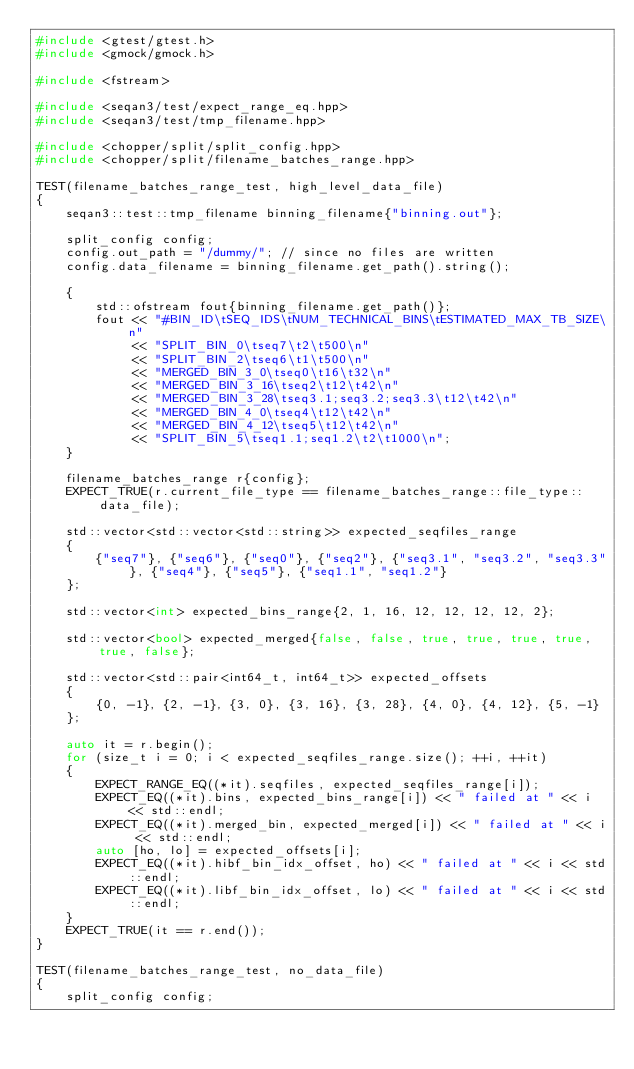<code> <loc_0><loc_0><loc_500><loc_500><_C++_>#include <gtest/gtest.h>
#include <gmock/gmock.h>

#include <fstream>

#include <seqan3/test/expect_range_eq.hpp>
#include <seqan3/test/tmp_filename.hpp>

#include <chopper/split/split_config.hpp>
#include <chopper/split/filename_batches_range.hpp>

TEST(filename_batches_range_test, high_level_data_file)
{
    seqan3::test::tmp_filename binning_filename{"binning.out"};

    split_config config;
    config.out_path = "/dummy/"; // since no files are written
    config.data_filename = binning_filename.get_path().string();

    {
        std::ofstream fout{binning_filename.get_path()};
        fout << "#BIN_ID\tSEQ_IDS\tNUM_TECHNICAL_BINS\tESTIMATED_MAX_TB_SIZE\n"
             << "SPLIT_BIN_0\tseq7\t2\t500\n"
             << "SPLIT_BIN_2\tseq6\t1\t500\n"
             << "MERGED_BIN_3_0\tseq0\t16\t32\n"
             << "MERGED_BIN_3_16\tseq2\t12\t42\n"
             << "MERGED_BIN_3_28\tseq3.1;seq3.2;seq3.3\t12\t42\n"
             << "MERGED_BIN_4_0\tseq4\t12\t42\n"
             << "MERGED_BIN_4_12\tseq5\t12\t42\n"
             << "SPLIT_BIN_5\tseq1.1;seq1.2\t2\t1000\n";
    }

    filename_batches_range r{config};
    EXPECT_TRUE(r.current_file_type == filename_batches_range::file_type::data_file);

    std::vector<std::vector<std::string>> expected_seqfiles_range
    {
        {"seq7"}, {"seq6"}, {"seq0"}, {"seq2"}, {"seq3.1", "seq3.2", "seq3.3"}, {"seq4"}, {"seq5"}, {"seq1.1", "seq1.2"}
    };

    std::vector<int> expected_bins_range{2, 1, 16, 12, 12, 12, 12, 2};

    std::vector<bool> expected_merged{false, false, true, true, true, true, true, false};

    std::vector<std::pair<int64_t, int64_t>> expected_offsets
    {
        {0, -1}, {2, -1}, {3, 0}, {3, 16}, {3, 28}, {4, 0}, {4, 12}, {5, -1}
    };

    auto it = r.begin();
    for (size_t i = 0; i < expected_seqfiles_range.size(); ++i, ++it)
    {
        EXPECT_RANGE_EQ((*it).seqfiles, expected_seqfiles_range[i]);
        EXPECT_EQ((*it).bins, expected_bins_range[i]) << " failed at " << i << std::endl;
        EXPECT_EQ((*it).merged_bin, expected_merged[i]) << " failed at " << i << std::endl;
        auto [ho, lo] = expected_offsets[i];
        EXPECT_EQ((*it).hibf_bin_idx_offset, ho) << " failed at " << i << std::endl;
        EXPECT_EQ((*it).libf_bin_idx_offset, lo) << " failed at " << i << std::endl;
    }
    EXPECT_TRUE(it == r.end());
}

TEST(filename_batches_range_test, no_data_file)
{
    split_config config;</code> 